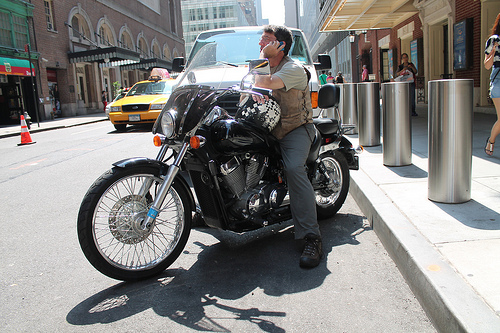Describe the architecture visible in the image. The architecture in the background suggests a metropolitan area with modern commercial buildings, featuring large glass windows and stone facades. 